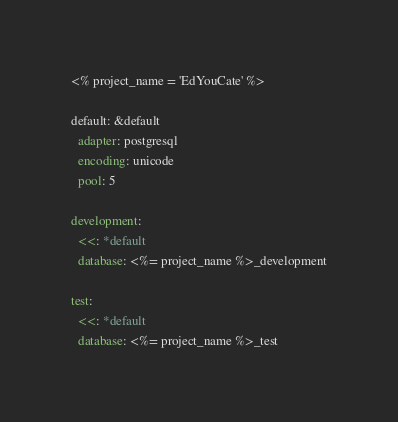Convert code to text. <code><loc_0><loc_0><loc_500><loc_500><_YAML_><% project_name = 'EdYouCate' %>

default: &default
  adapter: postgresql
  encoding: unicode
  pool: 5

development:
  <<: *default
  database: <%= project_name %>_development

test:
  <<: *default
  database: <%= project_name %>_test
</code> 